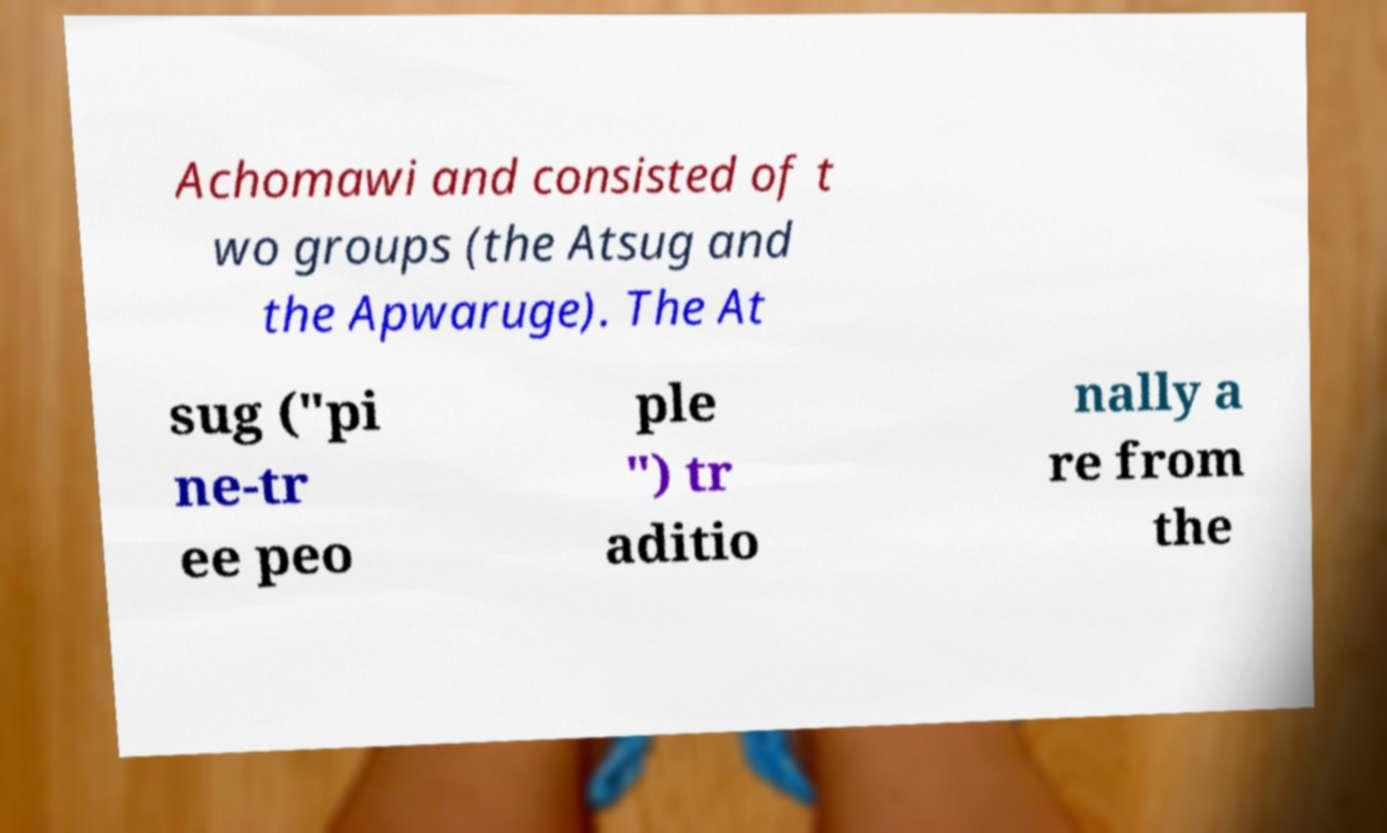Please read and relay the text visible in this image. What does it say? Achomawi and consisted of t wo groups (the Atsug and the Apwaruge). The At sug ("pi ne-tr ee peo ple ") tr aditio nally a re from the 